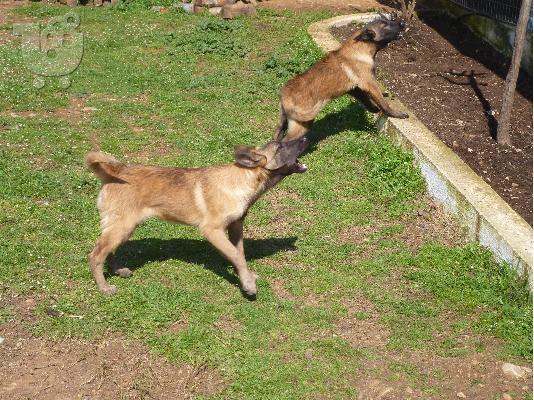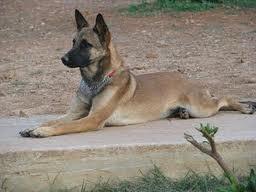The first image is the image on the left, the second image is the image on the right. Evaluate the accuracy of this statement regarding the images: "There are at least six dogs.". Is it true? Answer yes or no. No. 